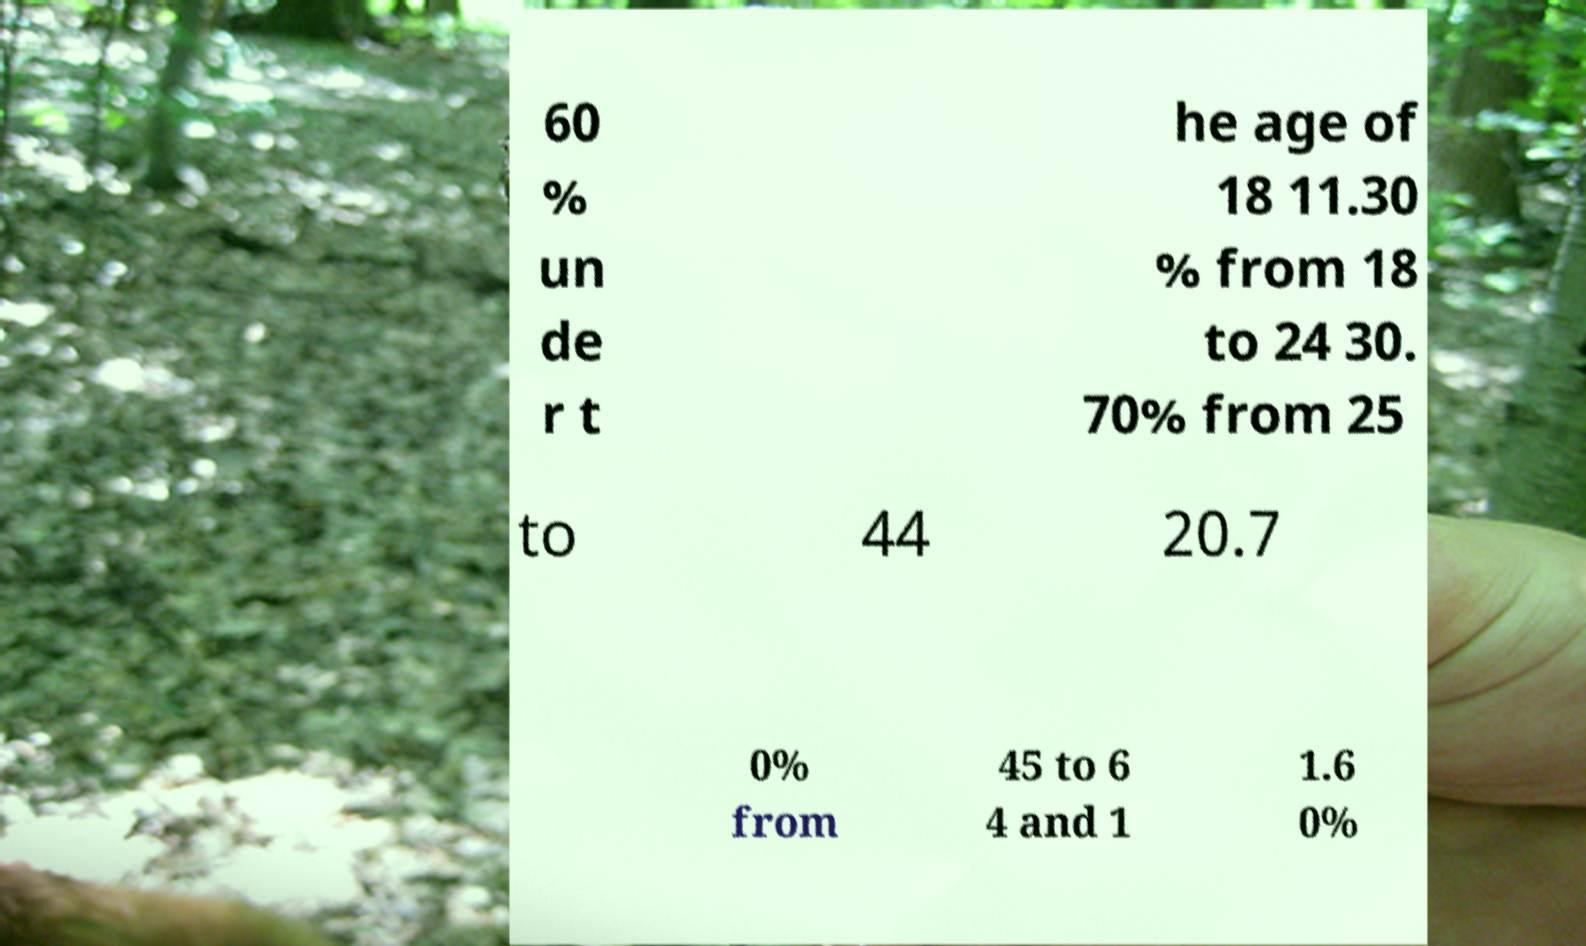There's text embedded in this image that I need extracted. Can you transcribe it verbatim? 60 % un de r t he age of 18 11.30 % from 18 to 24 30. 70% from 25 to 44 20.7 0% from 45 to 6 4 and 1 1.6 0% 